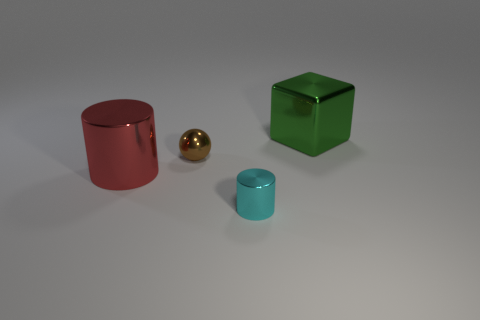Add 2 cylinders. How many objects exist? 6 Subtract all cubes. How many objects are left? 3 Subtract all cyan cylinders. How many cylinders are left? 1 Subtract all brown spheres. Subtract all green balls. How many objects are left? 3 Add 4 brown balls. How many brown balls are left? 5 Add 1 small yellow spheres. How many small yellow spheres exist? 1 Subtract 0 gray blocks. How many objects are left? 4 Subtract all red cylinders. Subtract all purple blocks. How many cylinders are left? 1 Subtract all gray cylinders. How many red spheres are left? 0 